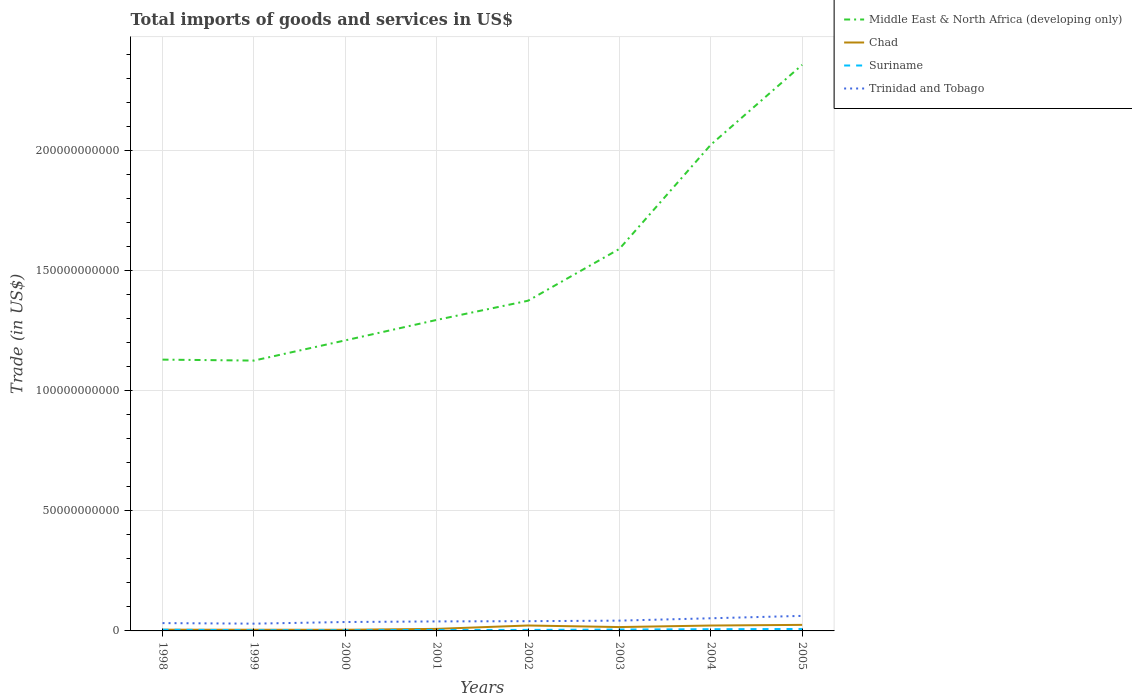Is the number of lines equal to the number of legend labels?
Keep it short and to the point. Yes. Across all years, what is the maximum total imports of goods and services in Middle East & North Africa (developing only)?
Give a very brief answer. 1.13e+11. In which year was the total imports of goods and services in Chad maximum?
Offer a very short reply. 2000. What is the total total imports of goods and services in Middle East & North Africa (developing only) in the graph?
Your answer should be very brief. -2.96e+1. What is the difference between the highest and the second highest total imports of goods and services in Suriname?
Give a very brief answer. 5.14e+08. How many years are there in the graph?
Your answer should be very brief. 8. What is the difference between two consecutive major ticks on the Y-axis?
Keep it short and to the point. 5.00e+1. Are the values on the major ticks of Y-axis written in scientific E-notation?
Provide a succinct answer. No. Does the graph contain any zero values?
Your response must be concise. No. Does the graph contain grids?
Offer a terse response. Yes. Where does the legend appear in the graph?
Your response must be concise. Top right. How many legend labels are there?
Your answer should be very brief. 4. What is the title of the graph?
Your answer should be very brief. Total imports of goods and services in US$. What is the label or title of the X-axis?
Your answer should be very brief. Years. What is the label or title of the Y-axis?
Provide a succinct answer. Trade (in US$). What is the Trade (in US$) in Middle East & North Africa (developing only) in 1998?
Keep it short and to the point. 1.13e+11. What is the Trade (in US$) of Chad in 1998?
Make the answer very short. 5.16e+08. What is the Trade (in US$) in Suriname in 1998?
Provide a short and direct response. 4.96e+08. What is the Trade (in US$) of Trinidad and Tobago in 1998?
Provide a succinct answer. 3.25e+09. What is the Trade (in US$) in Middle East & North Africa (developing only) in 1999?
Provide a short and direct response. 1.13e+11. What is the Trade (in US$) in Chad in 1999?
Give a very brief answer. 4.94e+08. What is the Trade (in US$) of Suriname in 1999?
Offer a very short reply. 2.98e+08. What is the Trade (in US$) of Trinidad and Tobago in 1999?
Your answer should be very brief. 3.03e+09. What is the Trade (in US$) of Middle East & North Africa (developing only) in 2000?
Give a very brief answer. 1.21e+11. What is the Trade (in US$) of Chad in 2000?
Give a very brief answer. 4.80e+08. What is the Trade (in US$) of Suriname in 2000?
Offer a terse response. 2.96e+08. What is the Trade (in US$) in Trinidad and Tobago in 2000?
Keep it short and to the point. 3.71e+09. What is the Trade (in US$) in Middle East & North Africa (developing only) in 2001?
Keep it short and to the point. 1.29e+11. What is the Trade (in US$) of Chad in 2001?
Keep it short and to the point. 8.49e+08. What is the Trade (in US$) of Suriname in 2001?
Give a very brief answer. 4.16e+08. What is the Trade (in US$) in Trinidad and Tobago in 2001?
Provide a short and direct response. 3.96e+09. What is the Trade (in US$) in Middle East & North Africa (developing only) in 2002?
Your answer should be compact. 1.37e+11. What is the Trade (in US$) in Chad in 2002?
Your answer should be very brief. 2.26e+09. What is the Trade (in US$) of Suriname in 2002?
Ensure brevity in your answer.  4.27e+08. What is the Trade (in US$) of Trinidad and Tobago in 2002?
Your response must be concise. 4.06e+09. What is the Trade (in US$) in Middle East & North Africa (developing only) in 2003?
Provide a short and direct response. 1.59e+11. What is the Trade (in US$) of Chad in 2003?
Your answer should be compact. 1.61e+09. What is the Trade (in US$) in Suriname in 2003?
Provide a short and direct response. 5.79e+08. What is the Trade (in US$) of Trinidad and Tobago in 2003?
Ensure brevity in your answer.  4.28e+09. What is the Trade (in US$) in Middle East & North Africa (developing only) in 2004?
Give a very brief answer. 2.02e+11. What is the Trade (in US$) in Chad in 2004?
Ensure brevity in your answer.  2.24e+09. What is the Trade (in US$) in Suriname in 2004?
Your answer should be compact. 7.14e+08. What is the Trade (in US$) in Trinidad and Tobago in 2004?
Keep it short and to the point. 5.26e+09. What is the Trade (in US$) of Middle East & North Africa (developing only) in 2005?
Give a very brief answer. 2.36e+11. What is the Trade (in US$) in Chad in 2005?
Your answer should be very brief. 2.52e+09. What is the Trade (in US$) of Suriname in 2005?
Offer a very short reply. 8.10e+08. What is the Trade (in US$) in Trinidad and Tobago in 2005?
Give a very brief answer. 6.27e+09. Across all years, what is the maximum Trade (in US$) of Middle East & North Africa (developing only)?
Offer a very short reply. 2.36e+11. Across all years, what is the maximum Trade (in US$) in Chad?
Your response must be concise. 2.52e+09. Across all years, what is the maximum Trade (in US$) in Suriname?
Provide a succinct answer. 8.10e+08. Across all years, what is the maximum Trade (in US$) of Trinidad and Tobago?
Provide a short and direct response. 6.27e+09. Across all years, what is the minimum Trade (in US$) of Middle East & North Africa (developing only)?
Offer a terse response. 1.13e+11. Across all years, what is the minimum Trade (in US$) of Chad?
Provide a short and direct response. 4.80e+08. Across all years, what is the minimum Trade (in US$) in Suriname?
Offer a very short reply. 2.96e+08. Across all years, what is the minimum Trade (in US$) of Trinidad and Tobago?
Offer a very short reply. 3.03e+09. What is the total Trade (in US$) of Middle East & North Africa (developing only) in the graph?
Your response must be concise. 1.21e+12. What is the total Trade (in US$) in Chad in the graph?
Offer a very short reply. 1.10e+1. What is the total Trade (in US$) in Suriname in the graph?
Your response must be concise. 4.04e+09. What is the total Trade (in US$) in Trinidad and Tobago in the graph?
Your answer should be compact. 3.38e+1. What is the difference between the Trade (in US$) in Middle East & North Africa (developing only) in 1998 and that in 1999?
Offer a very short reply. 4.03e+08. What is the difference between the Trade (in US$) of Chad in 1998 and that in 1999?
Provide a succinct answer. 2.19e+07. What is the difference between the Trade (in US$) of Suriname in 1998 and that in 1999?
Give a very brief answer. 1.98e+08. What is the difference between the Trade (in US$) in Trinidad and Tobago in 1998 and that in 1999?
Ensure brevity in your answer.  2.28e+08. What is the difference between the Trade (in US$) of Middle East & North Africa (developing only) in 1998 and that in 2000?
Your response must be concise. -8.01e+09. What is the difference between the Trade (in US$) of Chad in 1998 and that in 2000?
Your answer should be compact. 3.55e+07. What is the difference between the Trade (in US$) in Suriname in 1998 and that in 2000?
Ensure brevity in your answer.  2.00e+08. What is the difference between the Trade (in US$) of Trinidad and Tobago in 1998 and that in 2000?
Provide a succinct answer. -4.55e+08. What is the difference between the Trade (in US$) of Middle East & North Africa (developing only) in 1998 and that in 2001?
Provide a short and direct response. -1.65e+1. What is the difference between the Trade (in US$) of Chad in 1998 and that in 2001?
Keep it short and to the point. -3.33e+08. What is the difference between the Trade (in US$) of Suriname in 1998 and that in 2001?
Ensure brevity in your answer.  8.05e+07. What is the difference between the Trade (in US$) of Trinidad and Tobago in 1998 and that in 2001?
Provide a short and direct response. -7.02e+08. What is the difference between the Trade (in US$) of Middle East & North Africa (developing only) in 1998 and that in 2002?
Keep it short and to the point. -2.45e+1. What is the difference between the Trade (in US$) in Chad in 1998 and that in 2002?
Make the answer very short. -1.74e+09. What is the difference between the Trade (in US$) in Suriname in 1998 and that in 2002?
Ensure brevity in your answer.  6.91e+07. What is the difference between the Trade (in US$) in Trinidad and Tobago in 1998 and that in 2002?
Offer a very short reply. -8.00e+08. What is the difference between the Trade (in US$) in Middle East & North Africa (developing only) in 1998 and that in 2003?
Make the answer very short. -4.61e+1. What is the difference between the Trade (in US$) in Chad in 1998 and that in 2003?
Your answer should be very brief. -1.09e+09. What is the difference between the Trade (in US$) in Suriname in 1998 and that in 2003?
Provide a succinct answer. -8.31e+07. What is the difference between the Trade (in US$) of Trinidad and Tobago in 1998 and that in 2003?
Provide a succinct answer. -1.03e+09. What is the difference between the Trade (in US$) of Middle East & North Africa (developing only) in 1998 and that in 2004?
Ensure brevity in your answer.  -8.94e+1. What is the difference between the Trade (in US$) of Chad in 1998 and that in 2004?
Your response must be concise. -1.73e+09. What is the difference between the Trade (in US$) of Suriname in 1998 and that in 2004?
Keep it short and to the point. -2.18e+08. What is the difference between the Trade (in US$) of Trinidad and Tobago in 1998 and that in 2004?
Give a very brief answer. -2.01e+09. What is the difference between the Trade (in US$) in Middle East & North Africa (developing only) in 1998 and that in 2005?
Give a very brief answer. -1.23e+11. What is the difference between the Trade (in US$) in Chad in 1998 and that in 2005?
Offer a terse response. -2.00e+09. What is the difference between the Trade (in US$) in Suriname in 1998 and that in 2005?
Ensure brevity in your answer.  -3.14e+08. What is the difference between the Trade (in US$) in Trinidad and Tobago in 1998 and that in 2005?
Your answer should be compact. -3.01e+09. What is the difference between the Trade (in US$) of Middle East & North Africa (developing only) in 1999 and that in 2000?
Your answer should be compact. -8.42e+09. What is the difference between the Trade (in US$) of Chad in 1999 and that in 2000?
Your answer should be compact. 1.37e+07. What is the difference between the Trade (in US$) of Suriname in 1999 and that in 2000?
Provide a short and direct response. 1.62e+06. What is the difference between the Trade (in US$) in Trinidad and Tobago in 1999 and that in 2000?
Give a very brief answer. -6.83e+08. What is the difference between the Trade (in US$) in Middle East & North Africa (developing only) in 1999 and that in 2001?
Offer a terse response. -1.69e+1. What is the difference between the Trade (in US$) of Chad in 1999 and that in 2001?
Keep it short and to the point. -3.55e+08. What is the difference between the Trade (in US$) in Suriname in 1999 and that in 2001?
Offer a terse response. -1.18e+08. What is the difference between the Trade (in US$) of Trinidad and Tobago in 1999 and that in 2001?
Make the answer very short. -9.30e+08. What is the difference between the Trade (in US$) in Middle East & North Africa (developing only) in 1999 and that in 2002?
Keep it short and to the point. -2.49e+1. What is the difference between the Trade (in US$) in Chad in 1999 and that in 2002?
Keep it short and to the point. -1.77e+09. What is the difference between the Trade (in US$) in Suriname in 1999 and that in 2002?
Make the answer very short. -1.29e+08. What is the difference between the Trade (in US$) in Trinidad and Tobago in 1999 and that in 2002?
Your answer should be very brief. -1.03e+09. What is the difference between the Trade (in US$) of Middle East & North Africa (developing only) in 1999 and that in 2003?
Offer a very short reply. -4.65e+1. What is the difference between the Trade (in US$) in Chad in 1999 and that in 2003?
Give a very brief answer. -1.11e+09. What is the difference between the Trade (in US$) of Suriname in 1999 and that in 2003?
Provide a succinct answer. -2.81e+08. What is the difference between the Trade (in US$) in Trinidad and Tobago in 1999 and that in 2003?
Give a very brief answer. -1.26e+09. What is the difference between the Trade (in US$) in Middle East & North Africa (developing only) in 1999 and that in 2004?
Offer a very short reply. -8.98e+1. What is the difference between the Trade (in US$) in Chad in 1999 and that in 2004?
Give a very brief answer. -1.75e+09. What is the difference between the Trade (in US$) in Suriname in 1999 and that in 2004?
Your response must be concise. -4.16e+08. What is the difference between the Trade (in US$) of Trinidad and Tobago in 1999 and that in 2004?
Your response must be concise. -2.24e+09. What is the difference between the Trade (in US$) of Middle East & North Africa (developing only) in 1999 and that in 2005?
Ensure brevity in your answer.  -1.23e+11. What is the difference between the Trade (in US$) of Chad in 1999 and that in 2005?
Your answer should be compact. -2.02e+09. What is the difference between the Trade (in US$) of Suriname in 1999 and that in 2005?
Your answer should be compact. -5.12e+08. What is the difference between the Trade (in US$) of Trinidad and Tobago in 1999 and that in 2005?
Your response must be concise. -3.24e+09. What is the difference between the Trade (in US$) of Middle East & North Africa (developing only) in 2000 and that in 2001?
Provide a succinct answer. -8.51e+09. What is the difference between the Trade (in US$) of Chad in 2000 and that in 2001?
Offer a very short reply. -3.68e+08. What is the difference between the Trade (in US$) of Suriname in 2000 and that in 2001?
Offer a very short reply. -1.19e+08. What is the difference between the Trade (in US$) in Trinidad and Tobago in 2000 and that in 2001?
Provide a succinct answer. -2.47e+08. What is the difference between the Trade (in US$) in Middle East & North Africa (developing only) in 2000 and that in 2002?
Your response must be concise. -1.65e+1. What is the difference between the Trade (in US$) of Chad in 2000 and that in 2002?
Give a very brief answer. -1.78e+09. What is the difference between the Trade (in US$) of Suriname in 2000 and that in 2002?
Your answer should be compact. -1.31e+08. What is the difference between the Trade (in US$) in Trinidad and Tobago in 2000 and that in 2002?
Make the answer very short. -3.45e+08. What is the difference between the Trade (in US$) in Middle East & North Africa (developing only) in 2000 and that in 2003?
Your response must be concise. -3.81e+1. What is the difference between the Trade (in US$) of Chad in 2000 and that in 2003?
Provide a short and direct response. -1.13e+09. What is the difference between the Trade (in US$) in Suriname in 2000 and that in 2003?
Give a very brief answer. -2.83e+08. What is the difference between the Trade (in US$) of Trinidad and Tobago in 2000 and that in 2003?
Provide a short and direct response. -5.74e+08. What is the difference between the Trade (in US$) of Middle East & North Africa (developing only) in 2000 and that in 2004?
Keep it short and to the point. -8.14e+1. What is the difference between the Trade (in US$) of Chad in 2000 and that in 2004?
Your answer should be very brief. -1.76e+09. What is the difference between the Trade (in US$) of Suriname in 2000 and that in 2004?
Provide a short and direct response. -4.18e+08. What is the difference between the Trade (in US$) in Trinidad and Tobago in 2000 and that in 2004?
Your answer should be compact. -1.56e+09. What is the difference between the Trade (in US$) in Middle East & North Africa (developing only) in 2000 and that in 2005?
Provide a short and direct response. -1.15e+11. What is the difference between the Trade (in US$) of Chad in 2000 and that in 2005?
Ensure brevity in your answer.  -2.04e+09. What is the difference between the Trade (in US$) in Suriname in 2000 and that in 2005?
Your answer should be very brief. -5.14e+08. What is the difference between the Trade (in US$) of Trinidad and Tobago in 2000 and that in 2005?
Give a very brief answer. -2.56e+09. What is the difference between the Trade (in US$) in Middle East & North Africa (developing only) in 2001 and that in 2002?
Provide a succinct answer. -7.99e+09. What is the difference between the Trade (in US$) of Chad in 2001 and that in 2002?
Offer a very short reply. -1.41e+09. What is the difference between the Trade (in US$) in Suriname in 2001 and that in 2002?
Ensure brevity in your answer.  -1.14e+07. What is the difference between the Trade (in US$) in Trinidad and Tobago in 2001 and that in 2002?
Offer a terse response. -9.82e+07. What is the difference between the Trade (in US$) in Middle East & North Africa (developing only) in 2001 and that in 2003?
Keep it short and to the point. -2.96e+1. What is the difference between the Trade (in US$) in Chad in 2001 and that in 2003?
Offer a terse response. -7.59e+08. What is the difference between the Trade (in US$) in Suriname in 2001 and that in 2003?
Your answer should be compact. -1.64e+08. What is the difference between the Trade (in US$) of Trinidad and Tobago in 2001 and that in 2003?
Keep it short and to the point. -3.26e+08. What is the difference between the Trade (in US$) in Middle East & North Africa (developing only) in 2001 and that in 2004?
Your answer should be very brief. -7.29e+1. What is the difference between the Trade (in US$) of Chad in 2001 and that in 2004?
Your answer should be very brief. -1.39e+09. What is the difference between the Trade (in US$) in Suriname in 2001 and that in 2004?
Offer a terse response. -2.99e+08. What is the difference between the Trade (in US$) in Trinidad and Tobago in 2001 and that in 2004?
Keep it short and to the point. -1.31e+09. What is the difference between the Trade (in US$) in Middle East & North Africa (developing only) in 2001 and that in 2005?
Provide a succinct answer. -1.06e+11. What is the difference between the Trade (in US$) in Chad in 2001 and that in 2005?
Make the answer very short. -1.67e+09. What is the difference between the Trade (in US$) in Suriname in 2001 and that in 2005?
Your answer should be very brief. -3.94e+08. What is the difference between the Trade (in US$) in Trinidad and Tobago in 2001 and that in 2005?
Your answer should be compact. -2.31e+09. What is the difference between the Trade (in US$) in Middle East & North Africa (developing only) in 2002 and that in 2003?
Your response must be concise. -2.16e+1. What is the difference between the Trade (in US$) in Chad in 2002 and that in 2003?
Your answer should be very brief. 6.51e+08. What is the difference between the Trade (in US$) in Suriname in 2002 and that in 2003?
Your response must be concise. -1.52e+08. What is the difference between the Trade (in US$) in Trinidad and Tobago in 2002 and that in 2003?
Provide a succinct answer. -2.28e+08. What is the difference between the Trade (in US$) in Middle East & North Africa (developing only) in 2002 and that in 2004?
Ensure brevity in your answer.  -6.49e+1. What is the difference between the Trade (in US$) in Chad in 2002 and that in 2004?
Provide a succinct answer. 1.81e+07. What is the difference between the Trade (in US$) in Suriname in 2002 and that in 2004?
Your response must be concise. -2.87e+08. What is the difference between the Trade (in US$) in Trinidad and Tobago in 2002 and that in 2004?
Make the answer very short. -1.21e+09. What is the difference between the Trade (in US$) of Middle East & North Africa (developing only) in 2002 and that in 2005?
Give a very brief answer. -9.82e+1. What is the difference between the Trade (in US$) in Chad in 2002 and that in 2005?
Your answer should be compact. -2.58e+08. What is the difference between the Trade (in US$) in Suriname in 2002 and that in 2005?
Provide a short and direct response. -3.83e+08. What is the difference between the Trade (in US$) of Trinidad and Tobago in 2002 and that in 2005?
Make the answer very short. -2.21e+09. What is the difference between the Trade (in US$) of Middle East & North Africa (developing only) in 2003 and that in 2004?
Offer a terse response. -4.34e+1. What is the difference between the Trade (in US$) of Chad in 2003 and that in 2004?
Your answer should be compact. -6.33e+08. What is the difference between the Trade (in US$) in Suriname in 2003 and that in 2004?
Your response must be concise. -1.35e+08. What is the difference between the Trade (in US$) in Trinidad and Tobago in 2003 and that in 2004?
Ensure brevity in your answer.  -9.82e+08. What is the difference between the Trade (in US$) of Middle East & North Africa (developing only) in 2003 and that in 2005?
Offer a terse response. -7.66e+1. What is the difference between the Trade (in US$) of Chad in 2003 and that in 2005?
Your answer should be very brief. -9.09e+08. What is the difference between the Trade (in US$) of Suriname in 2003 and that in 2005?
Provide a succinct answer. -2.31e+08. What is the difference between the Trade (in US$) in Trinidad and Tobago in 2003 and that in 2005?
Your response must be concise. -1.98e+09. What is the difference between the Trade (in US$) of Middle East & North Africa (developing only) in 2004 and that in 2005?
Make the answer very short. -3.33e+1. What is the difference between the Trade (in US$) in Chad in 2004 and that in 2005?
Keep it short and to the point. -2.76e+08. What is the difference between the Trade (in US$) in Suriname in 2004 and that in 2005?
Provide a succinct answer. -9.59e+07. What is the difference between the Trade (in US$) in Trinidad and Tobago in 2004 and that in 2005?
Make the answer very short. -1.00e+09. What is the difference between the Trade (in US$) in Middle East & North Africa (developing only) in 1998 and the Trade (in US$) in Chad in 1999?
Provide a short and direct response. 1.12e+11. What is the difference between the Trade (in US$) in Middle East & North Africa (developing only) in 1998 and the Trade (in US$) in Suriname in 1999?
Your response must be concise. 1.13e+11. What is the difference between the Trade (in US$) of Middle East & North Africa (developing only) in 1998 and the Trade (in US$) of Trinidad and Tobago in 1999?
Your response must be concise. 1.10e+11. What is the difference between the Trade (in US$) in Chad in 1998 and the Trade (in US$) in Suriname in 1999?
Give a very brief answer. 2.18e+08. What is the difference between the Trade (in US$) of Chad in 1998 and the Trade (in US$) of Trinidad and Tobago in 1999?
Your response must be concise. -2.51e+09. What is the difference between the Trade (in US$) of Suriname in 1998 and the Trade (in US$) of Trinidad and Tobago in 1999?
Provide a succinct answer. -2.53e+09. What is the difference between the Trade (in US$) in Middle East & North Africa (developing only) in 1998 and the Trade (in US$) in Chad in 2000?
Offer a very short reply. 1.12e+11. What is the difference between the Trade (in US$) in Middle East & North Africa (developing only) in 1998 and the Trade (in US$) in Suriname in 2000?
Your response must be concise. 1.13e+11. What is the difference between the Trade (in US$) of Middle East & North Africa (developing only) in 1998 and the Trade (in US$) of Trinidad and Tobago in 2000?
Keep it short and to the point. 1.09e+11. What is the difference between the Trade (in US$) in Chad in 1998 and the Trade (in US$) in Suriname in 2000?
Your answer should be compact. 2.20e+08. What is the difference between the Trade (in US$) in Chad in 1998 and the Trade (in US$) in Trinidad and Tobago in 2000?
Your answer should be compact. -3.19e+09. What is the difference between the Trade (in US$) of Suriname in 1998 and the Trade (in US$) of Trinidad and Tobago in 2000?
Give a very brief answer. -3.21e+09. What is the difference between the Trade (in US$) in Middle East & North Africa (developing only) in 1998 and the Trade (in US$) in Chad in 2001?
Make the answer very short. 1.12e+11. What is the difference between the Trade (in US$) of Middle East & North Africa (developing only) in 1998 and the Trade (in US$) of Suriname in 2001?
Offer a very short reply. 1.13e+11. What is the difference between the Trade (in US$) of Middle East & North Africa (developing only) in 1998 and the Trade (in US$) of Trinidad and Tobago in 2001?
Your answer should be compact. 1.09e+11. What is the difference between the Trade (in US$) in Chad in 1998 and the Trade (in US$) in Suriname in 2001?
Provide a short and direct response. 1.00e+08. What is the difference between the Trade (in US$) in Chad in 1998 and the Trade (in US$) in Trinidad and Tobago in 2001?
Provide a succinct answer. -3.44e+09. What is the difference between the Trade (in US$) in Suriname in 1998 and the Trade (in US$) in Trinidad and Tobago in 2001?
Your answer should be compact. -3.46e+09. What is the difference between the Trade (in US$) in Middle East & North Africa (developing only) in 1998 and the Trade (in US$) in Chad in 2002?
Provide a short and direct response. 1.11e+11. What is the difference between the Trade (in US$) in Middle East & North Africa (developing only) in 1998 and the Trade (in US$) in Suriname in 2002?
Ensure brevity in your answer.  1.13e+11. What is the difference between the Trade (in US$) in Middle East & North Africa (developing only) in 1998 and the Trade (in US$) in Trinidad and Tobago in 2002?
Provide a short and direct response. 1.09e+11. What is the difference between the Trade (in US$) of Chad in 1998 and the Trade (in US$) of Suriname in 2002?
Make the answer very short. 8.90e+07. What is the difference between the Trade (in US$) of Chad in 1998 and the Trade (in US$) of Trinidad and Tobago in 2002?
Offer a very short reply. -3.54e+09. What is the difference between the Trade (in US$) in Suriname in 1998 and the Trade (in US$) in Trinidad and Tobago in 2002?
Keep it short and to the point. -3.56e+09. What is the difference between the Trade (in US$) in Middle East & North Africa (developing only) in 1998 and the Trade (in US$) in Chad in 2003?
Provide a succinct answer. 1.11e+11. What is the difference between the Trade (in US$) of Middle East & North Africa (developing only) in 1998 and the Trade (in US$) of Suriname in 2003?
Provide a short and direct response. 1.12e+11. What is the difference between the Trade (in US$) in Middle East & North Africa (developing only) in 1998 and the Trade (in US$) in Trinidad and Tobago in 2003?
Offer a terse response. 1.09e+11. What is the difference between the Trade (in US$) of Chad in 1998 and the Trade (in US$) of Suriname in 2003?
Provide a succinct answer. -6.32e+07. What is the difference between the Trade (in US$) in Chad in 1998 and the Trade (in US$) in Trinidad and Tobago in 2003?
Your answer should be very brief. -3.77e+09. What is the difference between the Trade (in US$) in Suriname in 1998 and the Trade (in US$) in Trinidad and Tobago in 2003?
Provide a succinct answer. -3.79e+09. What is the difference between the Trade (in US$) of Middle East & North Africa (developing only) in 1998 and the Trade (in US$) of Chad in 2004?
Provide a succinct answer. 1.11e+11. What is the difference between the Trade (in US$) in Middle East & North Africa (developing only) in 1998 and the Trade (in US$) in Suriname in 2004?
Your answer should be compact. 1.12e+11. What is the difference between the Trade (in US$) in Middle East & North Africa (developing only) in 1998 and the Trade (in US$) in Trinidad and Tobago in 2004?
Your response must be concise. 1.08e+11. What is the difference between the Trade (in US$) in Chad in 1998 and the Trade (in US$) in Suriname in 2004?
Keep it short and to the point. -1.98e+08. What is the difference between the Trade (in US$) of Chad in 1998 and the Trade (in US$) of Trinidad and Tobago in 2004?
Keep it short and to the point. -4.75e+09. What is the difference between the Trade (in US$) of Suriname in 1998 and the Trade (in US$) of Trinidad and Tobago in 2004?
Offer a terse response. -4.77e+09. What is the difference between the Trade (in US$) of Middle East & North Africa (developing only) in 1998 and the Trade (in US$) of Chad in 2005?
Ensure brevity in your answer.  1.10e+11. What is the difference between the Trade (in US$) in Middle East & North Africa (developing only) in 1998 and the Trade (in US$) in Suriname in 2005?
Provide a short and direct response. 1.12e+11. What is the difference between the Trade (in US$) of Middle East & North Africa (developing only) in 1998 and the Trade (in US$) of Trinidad and Tobago in 2005?
Provide a short and direct response. 1.07e+11. What is the difference between the Trade (in US$) in Chad in 1998 and the Trade (in US$) in Suriname in 2005?
Ensure brevity in your answer.  -2.94e+08. What is the difference between the Trade (in US$) of Chad in 1998 and the Trade (in US$) of Trinidad and Tobago in 2005?
Your response must be concise. -5.75e+09. What is the difference between the Trade (in US$) of Suriname in 1998 and the Trade (in US$) of Trinidad and Tobago in 2005?
Your answer should be very brief. -5.77e+09. What is the difference between the Trade (in US$) of Middle East & North Africa (developing only) in 1999 and the Trade (in US$) of Chad in 2000?
Keep it short and to the point. 1.12e+11. What is the difference between the Trade (in US$) in Middle East & North Africa (developing only) in 1999 and the Trade (in US$) in Suriname in 2000?
Provide a short and direct response. 1.12e+11. What is the difference between the Trade (in US$) of Middle East & North Africa (developing only) in 1999 and the Trade (in US$) of Trinidad and Tobago in 2000?
Give a very brief answer. 1.09e+11. What is the difference between the Trade (in US$) in Chad in 1999 and the Trade (in US$) in Suriname in 2000?
Your answer should be very brief. 1.98e+08. What is the difference between the Trade (in US$) of Chad in 1999 and the Trade (in US$) of Trinidad and Tobago in 2000?
Provide a succinct answer. -3.22e+09. What is the difference between the Trade (in US$) of Suriname in 1999 and the Trade (in US$) of Trinidad and Tobago in 2000?
Your response must be concise. -3.41e+09. What is the difference between the Trade (in US$) in Middle East & North Africa (developing only) in 1999 and the Trade (in US$) in Chad in 2001?
Keep it short and to the point. 1.12e+11. What is the difference between the Trade (in US$) of Middle East & North Africa (developing only) in 1999 and the Trade (in US$) of Suriname in 2001?
Make the answer very short. 1.12e+11. What is the difference between the Trade (in US$) in Middle East & North Africa (developing only) in 1999 and the Trade (in US$) in Trinidad and Tobago in 2001?
Offer a very short reply. 1.09e+11. What is the difference between the Trade (in US$) of Chad in 1999 and the Trade (in US$) of Suriname in 2001?
Provide a short and direct response. 7.85e+07. What is the difference between the Trade (in US$) in Chad in 1999 and the Trade (in US$) in Trinidad and Tobago in 2001?
Make the answer very short. -3.46e+09. What is the difference between the Trade (in US$) of Suriname in 1999 and the Trade (in US$) of Trinidad and Tobago in 2001?
Give a very brief answer. -3.66e+09. What is the difference between the Trade (in US$) of Middle East & North Africa (developing only) in 1999 and the Trade (in US$) of Chad in 2002?
Make the answer very short. 1.10e+11. What is the difference between the Trade (in US$) of Middle East & North Africa (developing only) in 1999 and the Trade (in US$) of Suriname in 2002?
Provide a succinct answer. 1.12e+11. What is the difference between the Trade (in US$) in Middle East & North Africa (developing only) in 1999 and the Trade (in US$) in Trinidad and Tobago in 2002?
Your answer should be very brief. 1.08e+11. What is the difference between the Trade (in US$) of Chad in 1999 and the Trade (in US$) of Suriname in 2002?
Your answer should be very brief. 6.71e+07. What is the difference between the Trade (in US$) in Chad in 1999 and the Trade (in US$) in Trinidad and Tobago in 2002?
Make the answer very short. -3.56e+09. What is the difference between the Trade (in US$) of Suriname in 1999 and the Trade (in US$) of Trinidad and Tobago in 2002?
Provide a short and direct response. -3.76e+09. What is the difference between the Trade (in US$) in Middle East & North Africa (developing only) in 1999 and the Trade (in US$) in Chad in 2003?
Ensure brevity in your answer.  1.11e+11. What is the difference between the Trade (in US$) in Middle East & North Africa (developing only) in 1999 and the Trade (in US$) in Suriname in 2003?
Ensure brevity in your answer.  1.12e+11. What is the difference between the Trade (in US$) in Middle East & North Africa (developing only) in 1999 and the Trade (in US$) in Trinidad and Tobago in 2003?
Your answer should be compact. 1.08e+11. What is the difference between the Trade (in US$) in Chad in 1999 and the Trade (in US$) in Suriname in 2003?
Ensure brevity in your answer.  -8.51e+07. What is the difference between the Trade (in US$) of Chad in 1999 and the Trade (in US$) of Trinidad and Tobago in 2003?
Your answer should be very brief. -3.79e+09. What is the difference between the Trade (in US$) of Suriname in 1999 and the Trade (in US$) of Trinidad and Tobago in 2003?
Provide a short and direct response. -3.99e+09. What is the difference between the Trade (in US$) of Middle East & North Africa (developing only) in 1999 and the Trade (in US$) of Chad in 2004?
Your answer should be compact. 1.10e+11. What is the difference between the Trade (in US$) in Middle East & North Africa (developing only) in 1999 and the Trade (in US$) in Suriname in 2004?
Make the answer very short. 1.12e+11. What is the difference between the Trade (in US$) in Middle East & North Africa (developing only) in 1999 and the Trade (in US$) in Trinidad and Tobago in 2004?
Make the answer very short. 1.07e+11. What is the difference between the Trade (in US$) of Chad in 1999 and the Trade (in US$) of Suriname in 2004?
Provide a short and direct response. -2.20e+08. What is the difference between the Trade (in US$) of Chad in 1999 and the Trade (in US$) of Trinidad and Tobago in 2004?
Your answer should be very brief. -4.77e+09. What is the difference between the Trade (in US$) in Suriname in 1999 and the Trade (in US$) in Trinidad and Tobago in 2004?
Ensure brevity in your answer.  -4.97e+09. What is the difference between the Trade (in US$) of Middle East & North Africa (developing only) in 1999 and the Trade (in US$) of Chad in 2005?
Keep it short and to the point. 1.10e+11. What is the difference between the Trade (in US$) in Middle East & North Africa (developing only) in 1999 and the Trade (in US$) in Suriname in 2005?
Make the answer very short. 1.12e+11. What is the difference between the Trade (in US$) in Middle East & North Africa (developing only) in 1999 and the Trade (in US$) in Trinidad and Tobago in 2005?
Your answer should be very brief. 1.06e+11. What is the difference between the Trade (in US$) of Chad in 1999 and the Trade (in US$) of Suriname in 2005?
Provide a short and direct response. -3.16e+08. What is the difference between the Trade (in US$) in Chad in 1999 and the Trade (in US$) in Trinidad and Tobago in 2005?
Provide a succinct answer. -5.77e+09. What is the difference between the Trade (in US$) in Suriname in 1999 and the Trade (in US$) in Trinidad and Tobago in 2005?
Your answer should be very brief. -5.97e+09. What is the difference between the Trade (in US$) in Middle East & North Africa (developing only) in 2000 and the Trade (in US$) in Chad in 2001?
Your response must be concise. 1.20e+11. What is the difference between the Trade (in US$) of Middle East & North Africa (developing only) in 2000 and the Trade (in US$) of Suriname in 2001?
Your response must be concise. 1.21e+11. What is the difference between the Trade (in US$) in Middle East & North Africa (developing only) in 2000 and the Trade (in US$) in Trinidad and Tobago in 2001?
Give a very brief answer. 1.17e+11. What is the difference between the Trade (in US$) in Chad in 2000 and the Trade (in US$) in Suriname in 2001?
Give a very brief answer. 6.48e+07. What is the difference between the Trade (in US$) of Chad in 2000 and the Trade (in US$) of Trinidad and Tobago in 2001?
Provide a succinct answer. -3.48e+09. What is the difference between the Trade (in US$) in Suriname in 2000 and the Trade (in US$) in Trinidad and Tobago in 2001?
Make the answer very short. -3.66e+09. What is the difference between the Trade (in US$) in Middle East & North Africa (developing only) in 2000 and the Trade (in US$) in Chad in 2002?
Provide a succinct answer. 1.19e+11. What is the difference between the Trade (in US$) in Middle East & North Africa (developing only) in 2000 and the Trade (in US$) in Suriname in 2002?
Offer a terse response. 1.21e+11. What is the difference between the Trade (in US$) of Middle East & North Africa (developing only) in 2000 and the Trade (in US$) of Trinidad and Tobago in 2002?
Your answer should be very brief. 1.17e+11. What is the difference between the Trade (in US$) in Chad in 2000 and the Trade (in US$) in Suriname in 2002?
Keep it short and to the point. 5.34e+07. What is the difference between the Trade (in US$) in Chad in 2000 and the Trade (in US$) in Trinidad and Tobago in 2002?
Make the answer very short. -3.57e+09. What is the difference between the Trade (in US$) of Suriname in 2000 and the Trade (in US$) of Trinidad and Tobago in 2002?
Your answer should be compact. -3.76e+09. What is the difference between the Trade (in US$) in Middle East & North Africa (developing only) in 2000 and the Trade (in US$) in Chad in 2003?
Your answer should be compact. 1.19e+11. What is the difference between the Trade (in US$) in Middle East & North Africa (developing only) in 2000 and the Trade (in US$) in Suriname in 2003?
Provide a short and direct response. 1.20e+11. What is the difference between the Trade (in US$) of Middle East & North Africa (developing only) in 2000 and the Trade (in US$) of Trinidad and Tobago in 2003?
Make the answer very short. 1.17e+11. What is the difference between the Trade (in US$) in Chad in 2000 and the Trade (in US$) in Suriname in 2003?
Give a very brief answer. -9.87e+07. What is the difference between the Trade (in US$) of Chad in 2000 and the Trade (in US$) of Trinidad and Tobago in 2003?
Provide a succinct answer. -3.80e+09. What is the difference between the Trade (in US$) of Suriname in 2000 and the Trade (in US$) of Trinidad and Tobago in 2003?
Keep it short and to the point. -3.99e+09. What is the difference between the Trade (in US$) of Middle East & North Africa (developing only) in 2000 and the Trade (in US$) of Chad in 2004?
Provide a succinct answer. 1.19e+11. What is the difference between the Trade (in US$) in Middle East & North Africa (developing only) in 2000 and the Trade (in US$) in Suriname in 2004?
Keep it short and to the point. 1.20e+11. What is the difference between the Trade (in US$) of Middle East & North Africa (developing only) in 2000 and the Trade (in US$) of Trinidad and Tobago in 2004?
Provide a succinct answer. 1.16e+11. What is the difference between the Trade (in US$) in Chad in 2000 and the Trade (in US$) in Suriname in 2004?
Provide a succinct answer. -2.34e+08. What is the difference between the Trade (in US$) of Chad in 2000 and the Trade (in US$) of Trinidad and Tobago in 2004?
Keep it short and to the point. -4.78e+09. What is the difference between the Trade (in US$) of Suriname in 2000 and the Trade (in US$) of Trinidad and Tobago in 2004?
Your response must be concise. -4.97e+09. What is the difference between the Trade (in US$) of Middle East & North Africa (developing only) in 2000 and the Trade (in US$) of Chad in 2005?
Offer a terse response. 1.18e+11. What is the difference between the Trade (in US$) of Middle East & North Africa (developing only) in 2000 and the Trade (in US$) of Suriname in 2005?
Offer a very short reply. 1.20e+11. What is the difference between the Trade (in US$) in Middle East & North Africa (developing only) in 2000 and the Trade (in US$) in Trinidad and Tobago in 2005?
Make the answer very short. 1.15e+11. What is the difference between the Trade (in US$) in Chad in 2000 and the Trade (in US$) in Suriname in 2005?
Ensure brevity in your answer.  -3.30e+08. What is the difference between the Trade (in US$) of Chad in 2000 and the Trade (in US$) of Trinidad and Tobago in 2005?
Your response must be concise. -5.79e+09. What is the difference between the Trade (in US$) of Suriname in 2000 and the Trade (in US$) of Trinidad and Tobago in 2005?
Offer a very short reply. -5.97e+09. What is the difference between the Trade (in US$) in Middle East & North Africa (developing only) in 2001 and the Trade (in US$) in Chad in 2002?
Your answer should be very brief. 1.27e+11. What is the difference between the Trade (in US$) of Middle East & North Africa (developing only) in 2001 and the Trade (in US$) of Suriname in 2002?
Give a very brief answer. 1.29e+11. What is the difference between the Trade (in US$) in Middle East & North Africa (developing only) in 2001 and the Trade (in US$) in Trinidad and Tobago in 2002?
Your answer should be compact. 1.25e+11. What is the difference between the Trade (in US$) of Chad in 2001 and the Trade (in US$) of Suriname in 2002?
Your answer should be very brief. 4.22e+08. What is the difference between the Trade (in US$) in Chad in 2001 and the Trade (in US$) in Trinidad and Tobago in 2002?
Offer a very short reply. -3.21e+09. What is the difference between the Trade (in US$) in Suriname in 2001 and the Trade (in US$) in Trinidad and Tobago in 2002?
Ensure brevity in your answer.  -3.64e+09. What is the difference between the Trade (in US$) of Middle East & North Africa (developing only) in 2001 and the Trade (in US$) of Chad in 2003?
Your answer should be compact. 1.28e+11. What is the difference between the Trade (in US$) of Middle East & North Africa (developing only) in 2001 and the Trade (in US$) of Suriname in 2003?
Your answer should be very brief. 1.29e+11. What is the difference between the Trade (in US$) of Middle East & North Africa (developing only) in 2001 and the Trade (in US$) of Trinidad and Tobago in 2003?
Provide a short and direct response. 1.25e+11. What is the difference between the Trade (in US$) of Chad in 2001 and the Trade (in US$) of Suriname in 2003?
Provide a short and direct response. 2.70e+08. What is the difference between the Trade (in US$) of Chad in 2001 and the Trade (in US$) of Trinidad and Tobago in 2003?
Your response must be concise. -3.43e+09. What is the difference between the Trade (in US$) in Suriname in 2001 and the Trade (in US$) in Trinidad and Tobago in 2003?
Offer a terse response. -3.87e+09. What is the difference between the Trade (in US$) in Middle East & North Africa (developing only) in 2001 and the Trade (in US$) in Chad in 2004?
Provide a short and direct response. 1.27e+11. What is the difference between the Trade (in US$) in Middle East & North Africa (developing only) in 2001 and the Trade (in US$) in Suriname in 2004?
Your answer should be very brief. 1.29e+11. What is the difference between the Trade (in US$) of Middle East & North Africa (developing only) in 2001 and the Trade (in US$) of Trinidad and Tobago in 2004?
Make the answer very short. 1.24e+11. What is the difference between the Trade (in US$) in Chad in 2001 and the Trade (in US$) in Suriname in 2004?
Ensure brevity in your answer.  1.35e+08. What is the difference between the Trade (in US$) in Chad in 2001 and the Trade (in US$) in Trinidad and Tobago in 2004?
Offer a terse response. -4.42e+09. What is the difference between the Trade (in US$) in Suriname in 2001 and the Trade (in US$) in Trinidad and Tobago in 2004?
Offer a terse response. -4.85e+09. What is the difference between the Trade (in US$) of Middle East & North Africa (developing only) in 2001 and the Trade (in US$) of Chad in 2005?
Make the answer very short. 1.27e+11. What is the difference between the Trade (in US$) of Middle East & North Africa (developing only) in 2001 and the Trade (in US$) of Suriname in 2005?
Offer a terse response. 1.29e+11. What is the difference between the Trade (in US$) of Middle East & North Africa (developing only) in 2001 and the Trade (in US$) of Trinidad and Tobago in 2005?
Your answer should be compact. 1.23e+11. What is the difference between the Trade (in US$) in Chad in 2001 and the Trade (in US$) in Suriname in 2005?
Offer a very short reply. 3.88e+07. What is the difference between the Trade (in US$) of Chad in 2001 and the Trade (in US$) of Trinidad and Tobago in 2005?
Ensure brevity in your answer.  -5.42e+09. What is the difference between the Trade (in US$) of Suriname in 2001 and the Trade (in US$) of Trinidad and Tobago in 2005?
Your answer should be very brief. -5.85e+09. What is the difference between the Trade (in US$) of Middle East & North Africa (developing only) in 2002 and the Trade (in US$) of Chad in 2003?
Offer a terse response. 1.36e+11. What is the difference between the Trade (in US$) of Middle East & North Africa (developing only) in 2002 and the Trade (in US$) of Suriname in 2003?
Provide a short and direct response. 1.37e+11. What is the difference between the Trade (in US$) in Middle East & North Africa (developing only) in 2002 and the Trade (in US$) in Trinidad and Tobago in 2003?
Keep it short and to the point. 1.33e+11. What is the difference between the Trade (in US$) in Chad in 2002 and the Trade (in US$) in Suriname in 2003?
Offer a very short reply. 1.68e+09. What is the difference between the Trade (in US$) in Chad in 2002 and the Trade (in US$) in Trinidad and Tobago in 2003?
Provide a succinct answer. -2.02e+09. What is the difference between the Trade (in US$) in Suriname in 2002 and the Trade (in US$) in Trinidad and Tobago in 2003?
Your answer should be very brief. -3.86e+09. What is the difference between the Trade (in US$) in Middle East & North Africa (developing only) in 2002 and the Trade (in US$) in Chad in 2004?
Your response must be concise. 1.35e+11. What is the difference between the Trade (in US$) in Middle East & North Africa (developing only) in 2002 and the Trade (in US$) in Suriname in 2004?
Offer a very short reply. 1.37e+11. What is the difference between the Trade (in US$) in Middle East & North Africa (developing only) in 2002 and the Trade (in US$) in Trinidad and Tobago in 2004?
Provide a succinct answer. 1.32e+11. What is the difference between the Trade (in US$) in Chad in 2002 and the Trade (in US$) in Suriname in 2004?
Give a very brief answer. 1.55e+09. What is the difference between the Trade (in US$) in Chad in 2002 and the Trade (in US$) in Trinidad and Tobago in 2004?
Your answer should be very brief. -3.01e+09. What is the difference between the Trade (in US$) in Suriname in 2002 and the Trade (in US$) in Trinidad and Tobago in 2004?
Your answer should be compact. -4.84e+09. What is the difference between the Trade (in US$) of Middle East & North Africa (developing only) in 2002 and the Trade (in US$) of Chad in 2005?
Your answer should be compact. 1.35e+11. What is the difference between the Trade (in US$) in Middle East & North Africa (developing only) in 2002 and the Trade (in US$) in Suriname in 2005?
Your answer should be very brief. 1.37e+11. What is the difference between the Trade (in US$) of Middle East & North Africa (developing only) in 2002 and the Trade (in US$) of Trinidad and Tobago in 2005?
Keep it short and to the point. 1.31e+11. What is the difference between the Trade (in US$) of Chad in 2002 and the Trade (in US$) of Suriname in 2005?
Provide a short and direct response. 1.45e+09. What is the difference between the Trade (in US$) in Chad in 2002 and the Trade (in US$) in Trinidad and Tobago in 2005?
Your answer should be compact. -4.01e+09. What is the difference between the Trade (in US$) of Suriname in 2002 and the Trade (in US$) of Trinidad and Tobago in 2005?
Offer a very short reply. -5.84e+09. What is the difference between the Trade (in US$) of Middle East & North Africa (developing only) in 2003 and the Trade (in US$) of Chad in 2004?
Provide a succinct answer. 1.57e+11. What is the difference between the Trade (in US$) of Middle East & North Africa (developing only) in 2003 and the Trade (in US$) of Suriname in 2004?
Offer a terse response. 1.58e+11. What is the difference between the Trade (in US$) in Middle East & North Africa (developing only) in 2003 and the Trade (in US$) in Trinidad and Tobago in 2004?
Provide a succinct answer. 1.54e+11. What is the difference between the Trade (in US$) in Chad in 2003 and the Trade (in US$) in Suriname in 2004?
Your answer should be very brief. 8.94e+08. What is the difference between the Trade (in US$) of Chad in 2003 and the Trade (in US$) of Trinidad and Tobago in 2004?
Ensure brevity in your answer.  -3.66e+09. What is the difference between the Trade (in US$) in Suriname in 2003 and the Trade (in US$) in Trinidad and Tobago in 2004?
Your response must be concise. -4.69e+09. What is the difference between the Trade (in US$) in Middle East & North Africa (developing only) in 2003 and the Trade (in US$) in Chad in 2005?
Make the answer very short. 1.57e+11. What is the difference between the Trade (in US$) of Middle East & North Africa (developing only) in 2003 and the Trade (in US$) of Suriname in 2005?
Keep it short and to the point. 1.58e+11. What is the difference between the Trade (in US$) of Middle East & North Africa (developing only) in 2003 and the Trade (in US$) of Trinidad and Tobago in 2005?
Your answer should be compact. 1.53e+11. What is the difference between the Trade (in US$) in Chad in 2003 and the Trade (in US$) in Suriname in 2005?
Give a very brief answer. 7.98e+08. What is the difference between the Trade (in US$) in Chad in 2003 and the Trade (in US$) in Trinidad and Tobago in 2005?
Keep it short and to the point. -4.66e+09. What is the difference between the Trade (in US$) of Suriname in 2003 and the Trade (in US$) of Trinidad and Tobago in 2005?
Your answer should be compact. -5.69e+09. What is the difference between the Trade (in US$) of Middle East & North Africa (developing only) in 2004 and the Trade (in US$) of Chad in 2005?
Provide a succinct answer. 2.00e+11. What is the difference between the Trade (in US$) in Middle East & North Africa (developing only) in 2004 and the Trade (in US$) in Suriname in 2005?
Provide a short and direct response. 2.02e+11. What is the difference between the Trade (in US$) in Middle East & North Africa (developing only) in 2004 and the Trade (in US$) in Trinidad and Tobago in 2005?
Keep it short and to the point. 1.96e+11. What is the difference between the Trade (in US$) of Chad in 2004 and the Trade (in US$) of Suriname in 2005?
Offer a terse response. 1.43e+09. What is the difference between the Trade (in US$) in Chad in 2004 and the Trade (in US$) in Trinidad and Tobago in 2005?
Give a very brief answer. -4.02e+09. What is the difference between the Trade (in US$) of Suriname in 2004 and the Trade (in US$) of Trinidad and Tobago in 2005?
Make the answer very short. -5.55e+09. What is the average Trade (in US$) in Middle East & North Africa (developing only) per year?
Your answer should be very brief. 1.51e+11. What is the average Trade (in US$) in Chad per year?
Provide a short and direct response. 1.37e+09. What is the average Trade (in US$) of Suriname per year?
Give a very brief answer. 5.04e+08. What is the average Trade (in US$) in Trinidad and Tobago per year?
Your answer should be very brief. 4.23e+09. In the year 1998, what is the difference between the Trade (in US$) of Middle East & North Africa (developing only) and Trade (in US$) of Chad?
Make the answer very short. 1.12e+11. In the year 1998, what is the difference between the Trade (in US$) in Middle East & North Africa (developing only) and Trade (in US$) in Suriname?
Give a very brief answer. 1.12e+11. In the year 1998, what is the difference between the Trade (in US$) of Middle East & North Africa (developing only) and Trade (in US$) of Trinidad and Tobago?
Your response must be concise. 1.10e+11. In the year 1998, what is the difference between the Trade (in US$) of Chad and Trade (in US$) of Suriname?
Offer a terse response. 1.99e+07. In the year 1998, what is the difference between the Trade (in US$) of Chad and Trade (in US$) of Trinidad and Tobago?
Give a very brief answer. -2.74e+09. In the year 1998, what is the difference between the Trade (in US$) of Suriname and Trade (in US$) of Trinidad and Tobago?
Keep it short and to the point. -2.76e+09. In the year 1999, what is the difference between the Trade (in US$) in Middle East & North Africa (developing only) and Trade (in US$) in Chad?
Offer a terse response. 1.12e+11. In the year 1999, what is the difference between the Trade (in US$) of Middle East & North Africa (developing only) and Trade (in US$) of Suriname?
Ensure brevity in your answer.  1.12e+11. In the year 1999, what is the difference between the Trade (in US$) of Middle East & North Africa (developing only) and Trade (in US$) of Trinidad and Tobago?
Ensure brevity in your answer.  1.10e+11. In the year 1999, what is the difference between the Trade (in US$) in Chad and Trade (in US$) in Suriname?
Provide a succinct answer. 1.96e+08. In the year 1999, what is the difference between the Trade (in US$) in Chad and Trade (in US$) in Trinidad and Tobago?
Make the answer very short. -2.53e+09. In the year 1999, what is the difference between the Trade (in US$) in Suriname and Trade (in US$) in Trinidad and Tobago?
Provide a succinct answer. -2.73e+09. In the year 2000, what is the difference between the Trade (in US$) in Middle East & North Africa (developing only) and Trade (in US$) in Chad?
Give a very brief answer. 1.20e+11. In the year 2000, what is the difference between the Trade (in US$) of Middle East & North Africa (developing only) and Trade (in US$) of Suriname?
Provide a short and direct response. 1.21e+11. In the year 2000, what is the difference between the Trade (in US$) in Middle East & North Africa (developing only) and Trade (in US$) in Trinidad and Tobago?
Ensure brevity in your answer.  1.17e+11. In the year 2000, what is the difference between the Trade (in US$) in Chad and Trade (in US$) in Suriname?
Ensure brevity in your answer.  1.84e+08. In the year 2000, what is the difference between the Trade (in US$) in Chad and Trade (in US$) in Trinidad and Tobago?
Provide a short and direct response. -3.23e+09. In the year 2000, what is the difference between the Trade (in US$) in Suriname and Trade (in US$) in Trinidad and Tobago?
Keep it short and to the point. -3.41e+09. In the year 2001, what is the difference between the Trade (in US$) of Middle East & North Africa (developing only) and Trade (in US$) of Chad?
Provide a succinct answer. 1.29e+11. In the year 2001, what is the difference between the Trade (in US$) of Middle East & North Africa (developing only) and Trade (in US$) of Suriname?
Your answer should be compact. 1.29e+11. In the year 2001, what is the difference between the Trade (in US$) of Middle East & North Africa (developing only) and Trade (in US$) of Trinidad and Tobago?
Keep it short and to the point. 1.26e+11. In the year 2001, what is the difference between the Trade (in US$) in Chad and Trade (in US$) in Suriname?
Your answer should be very brief. 4.33e+08. In the year 2001, what is the difference between the Trade (in US$) in Chad and Trade (in US$) in Trinidad and Tobago?
Give a very brief answer. -3.11e+09. In the year 2001, what is the difference between the Trade (in US$) of Suriname and Trade (in US$) of Trinidad and Tobago?
Your answer should be very brief. -3.54e+09. In the year 2002, what is the difference between the Trade (in US$) of Middle East & North Africa (developing only) and Trade (in US$) of Chad?
Your response must be concise. 1.35e+11. In the year 2002, what is the difference between the Trade (in US$) in Middle East & North Africa (developing only) and Trade (in US$) in Suriname?
Provide a short and direct response. 1.37e+11. In the year 2002, what is the difference between the Trade (in US$) of Middle East & North Africa (developing only) and Trade (in US$) of Trinidad and Tobago?
Provide a short and direct response. 1.33e+11. In the year 2002, what is the difference between the Trade (in US$) in Chad and Trade (in US$) in Suriname?
Offer a very short reply. 1.83e+09. In the year 2002, what is the difference between the Trade (in US$) of Chad and Trade (in US$) of Trinidad and Tobago?
Keep it short and to the point. -1.80e+09. In the year 2002, what is the difference between the Trade (in US$) in Suriname and Trade (in US$) in Trinidad and Tobago?
Your answer should be compact. -3.63e+09. In the year 2003, what is the difference between the Trade (in US$) in Middle East & North Africa (developing only) and Trade (in US$) in Chad?
Keep it short and to the point. 1.57e+11. In the year 2003, what is the difference between the Trade (in US$) of Middle East & North Africa (developing only) and Trade (in US$) of Suriname?
Offer a very short reply. 1.58e+11. In the year 2003, what is the difference between the Trade (in US$) in Middle East & North Africa (developing only) and Trade (in US$) in Trinidad and Tobago?
Offer a terse response. 1.55e+11. In the year 2003, what is the difference between the Trade (in US$) of Chad and Trade (in US$) of Suriname?
Your answer should be very brief. 1.03e+09. In the year 2003, what is the difference between the Trade (in US$) in Chad and Trade (in US$) in Trinidad and Tobago?
Your response must be concise. -2.68e+09. In the year 2003, what is the difference between the Trade (in US$) in Suriname and Trade (in US$) in Trinidad and Tobago?
Your answer should be very brief. -3.70e+09. In the year 2004, what is the difference between the Trade (in US$) in Middle East & North Africa (developing only) and Trade (in US$) in Chad?
Provide a succinct answer. 2.00e+11. In the year 2004, what is the difference between the Trade (in US$) in Middle East & North Africa (developing only) and Trade (in US$) in Suriname?
Provide a short and direct response. 2.02e+11. In the year 2004, what is the difference between the Trade (in US$) in Middle East & North Africa (developing only) and Trade (in US$) in Trinidad and Tobago?
Provide a succinct answer. 1.97e+11. In the year 2004, what is the difference between the Trade (in US$) in Chad and Trade (in US$) in Suriname?
Provide a short and direct response. 1.53e+09. In the year 2004, what is the difference between the Trade (in US$) of Chad and Trade (in US$) of Trinidad and Tobago?
Provide a short and direct response. -3.02e+09. In the year 2004, what is the difference between the Trade (in US$) of Suriname and Trade (in US$) of Trinidad and Tobago?
Your response must be concise. -4.55e+09. In the year 2005, what is the difference between the Trade (in US$) of Middle East & North Africa (developing only) and Trade (in US$) of Chad?
Your answer should be very brief. 2.33e+11. In the year 2005, what is the difference between the Trade (in US$) of Middle East & North Africa (developing only) and Trade (in US$) of Suriname?
Make the answer very short. 2.35e+11. In the year 2005, what is the difference between the Trade (in US$) of Middle East & North Africa (developing only) and Trade (in US$) of Trinidad and Tobago?
Ensure brevity in your answer.  2.29e+11. In the year 2005, what is the difference between the Trade (in US$) of Chad and Trade (in US$) of Suriname?
Your response must be concise. 1.71e+09. In the year 2005, what is the difference between the Trade (in US$) in Chad and Trade (in US$) in Trinidad and Tobago?
Ensure brevity in your answer.  -3.75e+09. In the year 2005, what is the difference between the Trade (in US$) in Suriname and Trade (in US$) in Trinidad and Tobago?
Provide a short and direct response. -5.46e+09. What is the ratio of the Trade (in US$) in Middle East & North Africa (developing only) in 1998 to that in 1999?
Make the answer very short. 1. What is the ratio of the Trade (in US$) of Chad in 1998 to that in 1999?
Give a very brief answer. 1.04. What is the ratio of the Trade (in US$) of Suriname in 1998 to that in 1999?
Make the answer very short. 1.67. What is the ratio of the Trade (in US$) in Trinidad and Tobago in 1998 to that in 1999?
Provide a succinct answer. 1.08. What is the ratio of the Trade (in US$) of Middle East & North Africa (developing only) in 1998 to that in 2000?
Make the answer very short. 0.93. What is the ratio of the Trade (in US$) of Chad in 1998 to that in 2000?
Give a very brief answer. 1.07. What is the ratio of the Trade (in US$) in Suriname in 1998 to that in 2000?
Offer a very short reply. 1.67. What is the ratio of the Trade (in US$) in Trinidad and Tobago in 1998 to that in 2000?
Offer a terse response. 0.88. What is the ratio of the Trade (in US$) of Middle East & North Africa (developing only) in 1998 to that in 2001?
Offer a very short reply. 0.87. What is the ratio of the Trade (in US$) in Chad in 1998 to that in 2001?
Provide a short and direct response. 0.61. What is the ratio of the Trade (in US$) in Suriname in 1998 to that in 2001?
Keep it short and to the point. 1.19. What is the ratio of the Trade (in US$) in Trinidad and Tobago in 1998 to that in 2001?
Keep it short and to the point. 0.82. What is the ratio of the Trade (in US$) of Middle East & North Africa (developing only) in 1998 to that in 2002?
Provide a succinct answer. 0.82. What is the ratio of the Trade (in US$) in Chad in 1998 to that in 2002?
Give a very brief answer. 0.23. What is the ratio of the Trade (in US$) in Suriname in 1998 to that in 2002?
Give a very brief answer. 1.16. What is the ratio of the Trade (in US$) of Trinidad and Tobago in 1998 to that in 2002?
Your response must be concise. 0.8. What is the ratio of the Trade (in US$) in Middle East & North Africa (developing only) in 1998 to that in 2003?
Offer a very short reply. 0.71. What is the ratio of the Trade (in US$) of Chad in 1998 to that in 2003?
Your response must be concise. 0.32. What is the ratio of the Trade (in US$) of Suriname in 1998 to that in 2003?
Your answer should be compact. 0.86. What is the ratio of the Trade (in US$) in Trinidad and Tobago in 1998 to that in 2003?
Make the answer very short. 0.76. What is the ratio of the Trade (in US$) of Middle East & North Africa (developing only) in 1998 to that in 2004?
Provide a short and direct response. 0.56. What is the ratio of the Trade (in US$) of Chad in 1998 to that in 2004?
Your answer should be very brief. 0.23. What is the ratio of the Trade (in US$) of Suriname in 1998 to that in 2004?
Offer a terse response. 0.69. What is the ratio of the Trade (in US$) in Trinidad and Tobago in 1998 to that in 2004?
Your response must be concise. 0.62. What is the ratio of the Trade (in US$) in Middle East & North Africa (developing only) in 1998 to that in 2005?
Provide a succinct answer. 0.48. What is the ratio of the Trade (in US$) of Chad in 1998 to that in 2005?
Keep it short and to the point. 0.2. What is the ratio of the Trade (in US$) of Suriname in 1998 to that in 2005?
Provide a short and direct response. 0.61. What is the ratio of the Trade (in US$) in Trinidad and Tobago in 1998 to that in 2005?
Give a very brief answer. 0.52. What is the ratio of the Trade (in US$) in Middle East & North Africa (developing only) in 1999 to that in 2000?
Offer a very short reply. 0.93. What is the ratio of the Trade (in US$) of Chad in 1999 to that in 2000?
Your response must be concise. 1.03. What is the ratio of the Trade (in US$) of Trinidad and Tobago in 1999 to that in 2000?
Provide a succinct answer. 0.82. What is the ratio of the Trade (in US$) of Middle East & North Africa (developing only) in 1999 to that in 2001?
Your response must be concise. 0.87. What is the ratio of the Trade (in US$) of Chad in 1999 to that in 2001?
Ensure brevity in your answer.  0.58. What is the ratio of the Trade (in US$) of Suriname in 1999 to that in 2001?
Your answer should be compact. 0.72. What is the ratio of the Trade (in US$) of Trinidad and Tobago in 1999 to that in 2001?
Your response must be concise. 0.77. What is the ratio of the Trade (in US$) of Middle East & North Africa (developing only) in 1999 to that in 2002?
Make the answer very short. 0.82. What is the ratio of the Trade (in US$) in Chad in 1999 to that in 2002?
Provide a short and direct response. 0.22. What is the ratio of the Trade (in US$) of Suriname in 1999 to that in 2002?
Provide a succinct answer. 0.7. What is the ratio of the Trade (in US$) in Trinidad and Tobago in 1999 to that in 2002?
Your answer should be compact. 0.75. What is the ratio of the Trade (in US$) in Middle East & North Africa (developing only) in 1999 to that in 2003?
Provide a short and direct response. 0.71. What is the ratio of the Trade (in US$) in Chad in 1999 to that in 2003?
Give a very brief answer. 0.31. What is the ratio of the Trade (in US$) in Suriname in 1999 to that in 2003?
Your answer should be compact. 0.51. What is the ratio of the Trade (in US$) of Trinidad and Tobago in 1999 to that in 2003?
Provide a succinct answer. 0.71. What is the ratio of the Trade (in US$) of Middle East & North Africa (developing only) in 1999 to that in 2004?
Offer a terse response. 0.56. What is the ratio of the Trade (in US$) of Chad in 1999 to that in 2004?
Offer a very short reply. 0.22. What is the ratio of the Trade (in US$) of Suriname in 1999 to that in 2004?
Keep it short and to the point. 0.42. What is the ratio of the Trade (in US$) in Trinidad and Tobago in 1999 to that in 2004?
Ensure brevity in your answer.  0.57. What is the ratio of the Trade (in US$) of Middle East & North Africa (developing only) in 1999 to that in 2005?
Make the answer very short. 0.48. What is the ratio of the Trade (in US$) of Chad in 1999 to that in 2005?
Provide a succinct answer. 0.2. What is the ratio of the Trade (in US$) of Suriname in 1999 to that in 2005?
Give a very brief answer. 0.37. What is the ratio of the Trade (in US$) of Trinidad and Tobago in 1999 to that in 2005?
Make the answer very short. 0.48. What is the ratio of the Trade (in US$) in Middle East & North Africa (developing only) in 2000 to that in 2001?
Give a very brief answer. 0.93. What is the ratio of the Trade (in US$) in Chad in 2000 to that in 2001?
Ensure brevity in your answer.  0.57. What is the ratio of the Trade (in US$) in Suriname in 2000 to that in 2001?
Provide a short and direct response. 0.71. What is the ratio of the Trade (in US$) in Middle East & North Africa (developing only) in 2000 to that in 2002?
Give a very brief answer. 0.88. What is the ratio of the Trade (in US$) of Chad in 2000 to that in 2002?
Provide a short and direct response. 0.21. What is the ratio of the Trade (in US$) of Suriname in 2000 to that in 2002?
Provide a short and direct response. 0.69. What is the ratio of the Trade (in US$) of Trinidad and Tobago in 2000 to that in 2002?
Give a very brief answer. 0.91. What is the ratio of the Trade (in US$) in Middle East & North Africa (developing only) in 2000 to that in 2003?
Your response must be concise. 0.76. What is the ratio of the Trade (in US$) in Chad in 2000 to that in 2003?
Your response must be concise. 0.3. What is the ratio of the Trade (in US$) in Suriname in 2000 to that in 2003?
Offer a terse response. 0.51. What is the ratio of the Trade (in US$) of Trinidad and Tobago in 2000 to that in 2003?
Your response must be concise. 0.87. What is the ratio of the Trade (in US$) of Middle East & North Africa (developing only) in 2000 to that in 2004?
Provide a succinct answer. 0.6. What is the ratio of the Trade (in US$) in Chad in 2000 to that in 2004?
Make the answer very short. 0.21. What is the ratio of the Trade (in US$) of Suriname in 2000 to that in 2004?
Offer a very short reply. 0.41. What is the ratio of the Trade (in US$) of Trinidad and Tobago in 2000 to that in 2004?
Give a very brief answer. 0.7. What is the ratio of the Trade (in US$) in Middle East & North Africa (developing only) in 2000 to that in 2005?
Your answer should be very brief. 0.51. What is the ratio of the Trade (in US$) in Chad in 2000 to that in 2005?
Ensure brevity in your answer.  0.19. What is the ratio of the Trade (in US$) in Suriname in 2000 to that in 2005?
Make the answer very short. 0.37. What is the ratio of the Trade (in US$) of Trinidad and Tobago in 2000 to that in 2005?
Your answer should be compact. 0.59. What is the ratio of the Trade (in US$) of Middle East & North Africa (developing only) in 2001 to that in 2002?
Offer a very short reply. 0.94. What is the ratio of the Trade (in US$) of Chad in 2001 to that in 2002?
Keep it short and to the point. 0.38. What is the ratio of the Trade (in US$) in Suriname in 2001 to that in 2002?
Provide a short and direct response. 0.97. What is the ratio of the Trade (in US$) in Trinidad and Tobago in 2001 to that in 2002?
Provide a short and direct response. 0.98. What is the ratio of the Trade (in US$) in Middle East & North Africa (developing only) in 2001 to that in 2003?
Ensure brevity in your answer.  0.81. What is the ratio of the Trade (in US$) of Chad in 2001 to that in 2003?
Ensure brevity in your answer.  0.53. What is the ratio of the Trade (in US$) in Suriname in 2001 to that in 2003?
Give a very brief answer. 0.72. What is the ratio of the Trade (in US$) of Trinidad and Tobago in 2001 to that in 2003?
Provide a short and direct response. 0.92. What is the ratio of the Trade (in US$) in Middle East & North Africa (developing only) in 2001 to that in 2004?
Your answer should be compact. 0.64. What is the ratio of the Trade (in US$) in Chad in 2001 to that in 2004?
Ensure brevity in your answer.  0.38. What is the ratio of the Trade (in US$) of Suriname in 2001 to that in 2004?
Ensure brevity in your answer.  0.58. What is the ratio of the Trade (in US$) of Trinidad and Tobago in 2001 to that in 2004?
Ensure brevity in your answer.  0.75. What is the ratio of the Trade (in US$) of Middle East & North Africa (developing only) in 2001 to that in 2005?
Your response must be concise. 0.55. What is the ratio of the Trade (in US$) in Chad in 2001 to that in 2005?
Give a very brief answer. 0.34. What is the ratio of the Trade (in US$) in Suriname in 2001 to that in 2005?
Give a very brief answer. 0.51. What is the ratio of the Trade (in US$) of Trinidad and Tobago in 2001 to that in 2005?
Your answer should be very brief. 0.63. What is the ratio of the Trade (in US$) in Middle East & North Africa (developing only) in 2002 to that in 2003?
Give a very brief answer. 0.86. What is the ratio of the Trade (in US$) of Chad in 2002 to that in 2003?
Keep it short and to the point. 1.41. What is the ratio of the Trade (in US$) in Suriname in 2002 to that in 2003?
Give a very brief answer. 0.74. What is the ratio of the Trade (in US$) of Trinidad and Tobago in 2002 to that in 2003?
Provide a succinct answer. 0.95. What is the ratio of the Trade (in US$) of Middle East & North Africa (developing only) in 2002 to that in 2004?
Provide a short and direct response. 0.68. What is the ratio of the Trade (in US$) in Suriname in 2002 to that in 2004?
Offer a terse response. 0.6. What is the ratio of the Trade (in US$) in Trinidad and Tobago in 2002 to that in 2004?
Your answer should be compact. 0.77. What is the ratio of the Trade (in US$) of Middle East & North Africa (developing only) in 2002 to that in 2005?
Your answer should be very brief. 0.58. What is the ratio of the Trade (in US$) of Chad in 2002 to that in 2005?
Provide a short and direct response. 0.9. What is the ratio of the Trade (in US$) in Suriname in 2002 to that in 2005?
Offer a terse response. 0.53. What is the ratio of the Trade (in US$) of Trinidad and Tobago in 2002 to that in 2005?
Offer a terse response. 0.65. What is the ratio of the Trade (in US$) in Middle East & North Africa (developing only) in 2003 to that in 2004?
Provide a succinct answer. 0.79. What is the ratio of the Trade (in US$) of Chad in 2003 to that in 2004?
Provide a succinct answer. 0.72. What is the ratio of the Trade (in US$) in Suriname in 2003 to that in 2004?
Your answer should be very brief. 0.81. What is the ratio of the Trade (in US$) of Trinidad and Tobago in 2003 to that in 2004?
Provide a succinct answer. 0.81. What is the ratio of the Trade (in US$) in Middle East & North Africa (developing only) in 2003 to that in 2005?
Offer a terse response. 0.67. What is the ratio of the Trade (in US$) of Chad in 2003 to that in 2005?
Your answer should be compact. 0.64. What is the ratio of the Trade (in US$) of Suriname in 2003 to that in 2005?
Your answer should be very brief. 0.71. What is the ratio of the Trade (in US$) in Trinidad and Tobago in 2003 to that in 2005?
Your response must be concise. 0.68. What is the ratio of the Trade (in US$) in Middle East & North Africa (developing only) in 2004 to that in 2005?
Your response must be concise. 0.86. What is the ratio of the Trade (in US$) of Chad in 2004 to that in 2005?
Your response must be concise. 0.89. What is the ratio of the Trade (in US$) of Suriname in 2004 to that in 2005?
Your response must be concise. 0.88. What is the ratio of the Trade (in US$) in Trinidad and Tobago in 2004 to that in 2005?
Give a very brief answer. 0.84. What is the difference between the highest and the second highest Trade (in US$) of Middle East & North Africa (developing only)?
Offer a terse response. 3.33e+1. What is the difference between the highest and the second highest Trade (in US$) in Chad?
Make the answer very short. 2.58e+08. What is the difference between the highest and the second highest Trade (in US$) of Suriname?
Offer a terse response. 9.59e+07. What is the difference between the highest and the second highest Trade (in US$) of Trinidad and Tobago?
Offer a terse response. 1.00e+09. What is the difference between the highest and the lowest Trade (in US$) in Middle East & North Africa (developing only)?
Your answer should be compact. 1.23e+11. What is the difference between the highest and the lowest Trade (in US$) in Chad?
Your answer should be compact. 2.04e+09. What is the difference between the highest and the lowest Trade (in US$) in Suriname?
Your response must be concise. 5.14e+08. What is the difference between the highest and the lowest Trade (in US$) of Trinidad and Tobago?
Provide a succinct answer. 3.24e+09. 